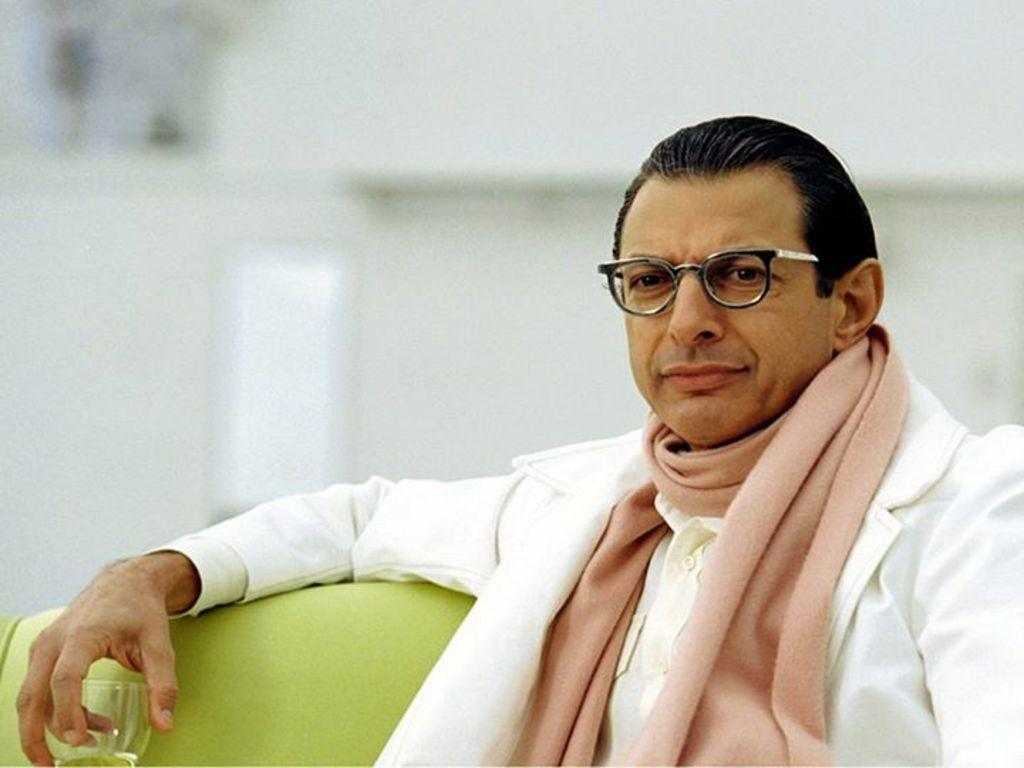What is the man in the image doing? The man is sitting in the image. What is the man wearing on his upper body? The man is wearing a suit, a muffler, and a shirt. What accessory is the man wearing on his face? The man is wearing spectacles. What object is the man holding in the image? The man is holding a glass. How would you describe the background of the image? The background of the image appears blurry. What type of produce can be seen growing in the background of the image? There is no produce visible in the image; the background appears blurry. What time of day is it in the image, based on the hour? The provided facts do not mention the time of day or any specific hour. 